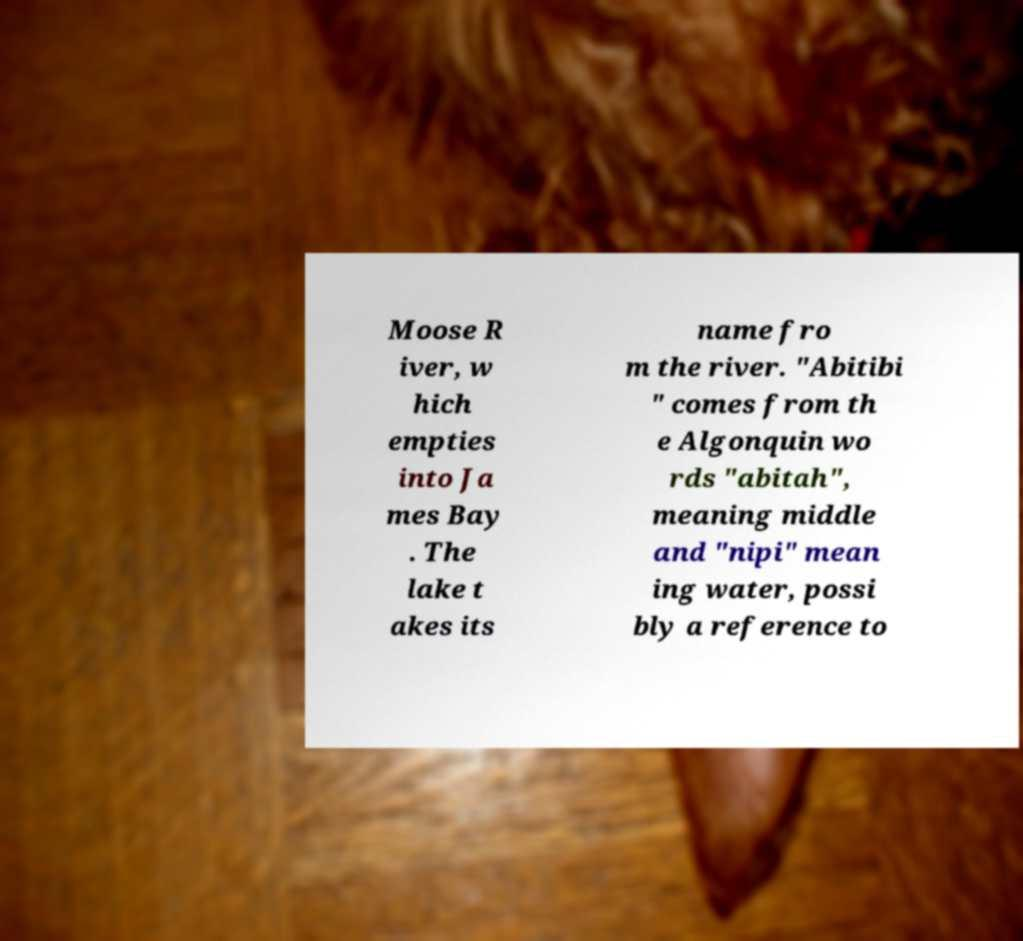I need the written content from this picture converted into text. Can you do that? Moose R iver, w hich empties into Ja mes Bay . The lake t akes its name fro m the river. "Abitibi " comes from th e Algonquin wo rds "abitah", meaning middle and "nipi" mean ing water, possi bly a reference to 